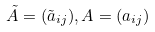<formula> <loc_0><loc_0><loc_500><loc_500>\tilde { A } = ( \tilde { a } _ { i j } ) , A = ( a _ { i j } )</formula> 